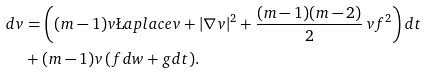Convert formula to latex. <formula><loc_0><loc_0><loc_500><loc_500>d v & = \left ( ( m - 1 ) v \L a p l a c e v + | \nabla v | ^ { 2 } + \frac { ( m - 1 ) ( m - 2 ) } { 2 } \, v f ^ { 2 } \right ) d t \\ & + ( m - 1 ) v \, ( f d w + g d t ) .</formula> 